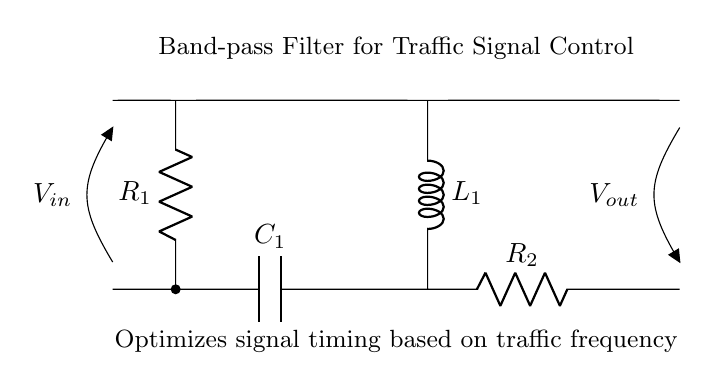What are the components in this circuit? The circuit includes a capacitor labeled C1, resistors labeled R1 and R2, and an inductor labeled L1.
Answer: Capacitor, Resistors, Inductor What is the purpose of the band-pass filter? The band-pass filter optimizes signal timing based on the frequencies of traffic, allowing specific frequency ranges to pass while blocking others to enhance signal control.
Answer: Optimize signal timing Which component has the highest position in the diagram? The capacitor C1 is positioned highest in the circuit diagram, connected to the input voltage source at the top.
Answer: Capacitor C1 What type of filter is represented in this circuit? The circuit diagram represents a band-pass filter, which allows frequencies within a certain range to pass while attenuating others.
Answer: Band-pass filter How many resistors are present in this circuit? There are two resistors, R1 and R2, which are essential components of the band-pass filter design.
Answer: Two resistors What is the voltage input symbol in the circuit? The voltage input is denoted by the symbol V in the circuit, labeled at the left side of the diagram at the input position.
Answer: V Explain how the inductor is connected to the circuit? The inductor L1 is connected in parallel with resistor R2 and connected to one end of the circuit that also bridges the input side with the output side. This connection allows it to filter signals effectively.
Answer: Parallel with R2 